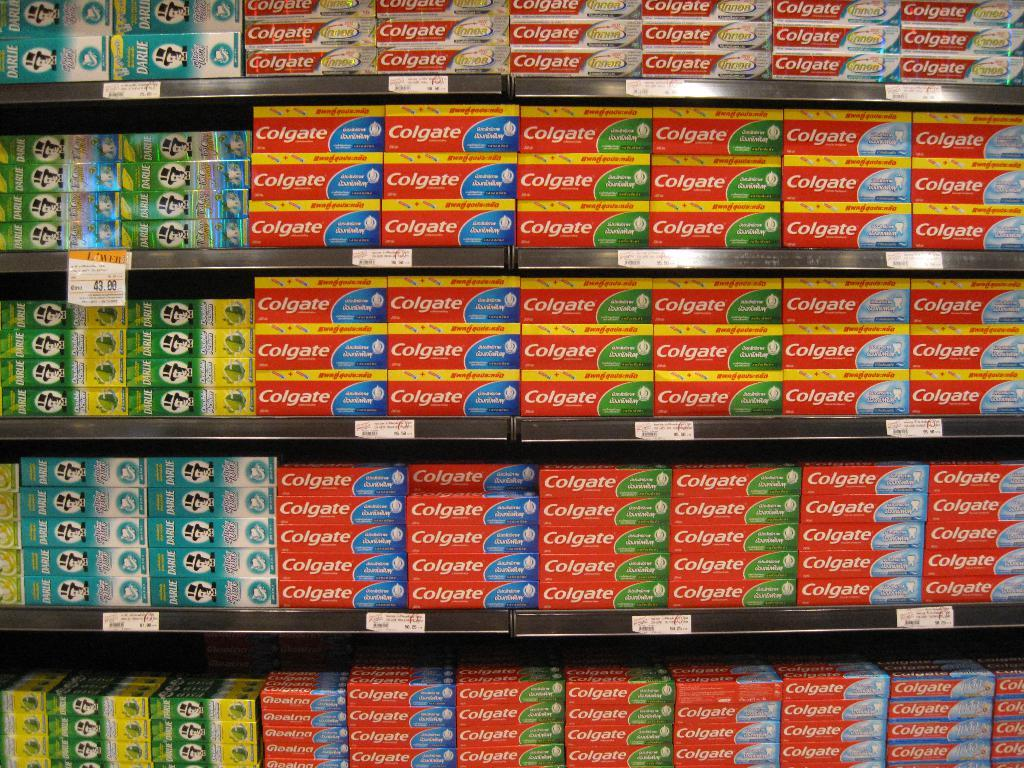<image>
Relay a brief, clear account of the picture shown. An aisle in a store containing toothpaste by Colgate 